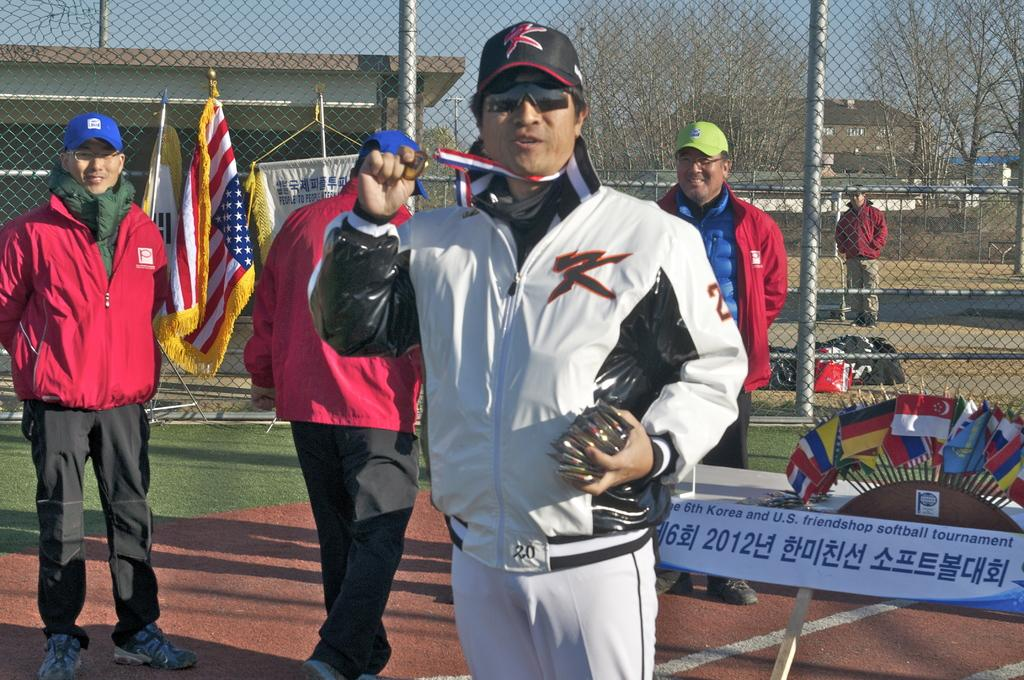Provide a one-sentence caption for the provided image. A man shows off his medal at the 6th Korean and U.S friendshop softball tournament. 